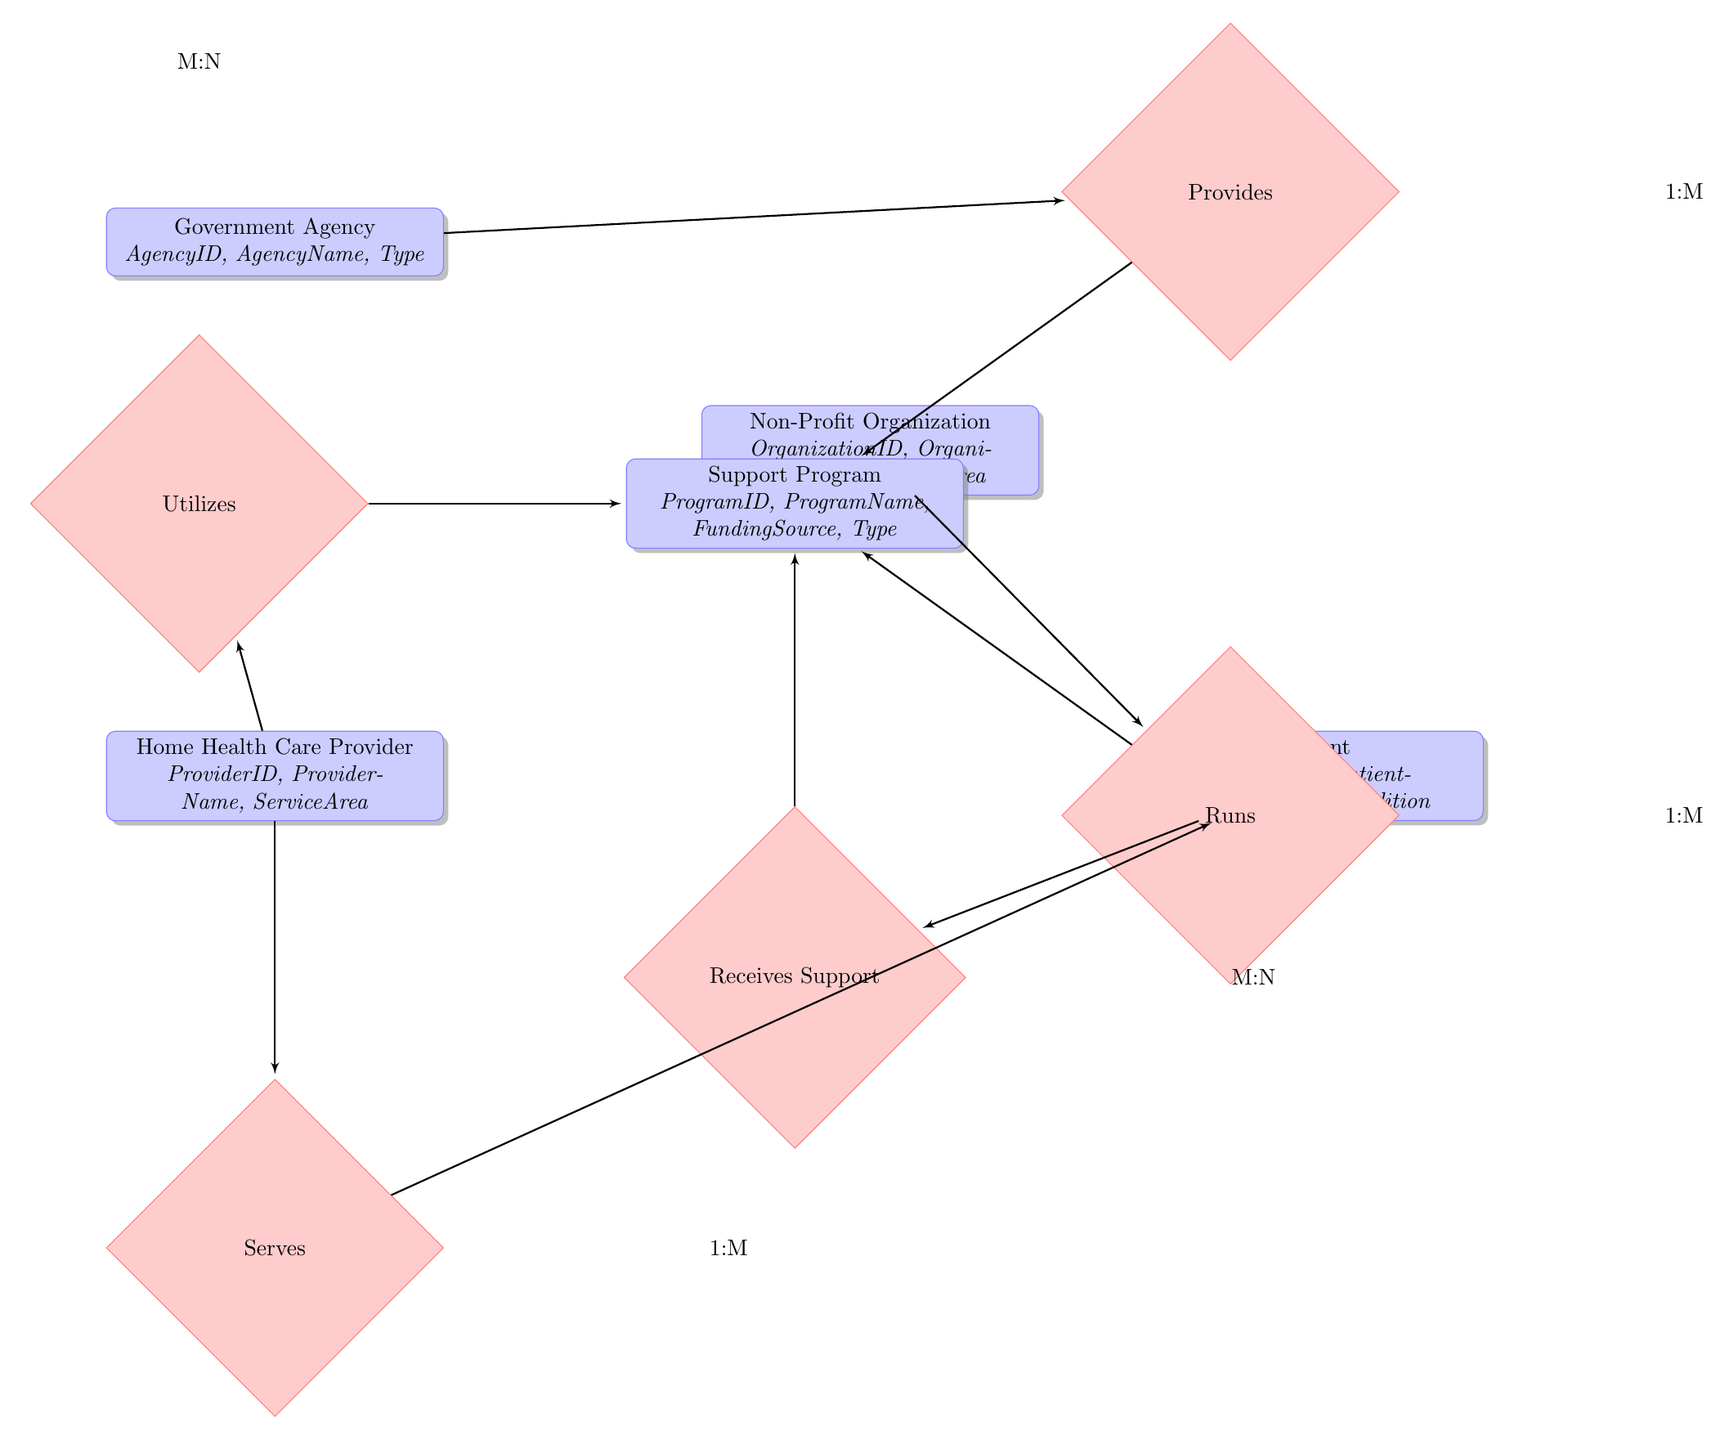What's the total number of entities in the diagram? There are five entities displayed in the diagram: Government Agency, Non-Profit Organization, Support Program, Home Health Care Provider, and Patient.
Answer: 5 What is the relationship type between Government Agency and Support Program? The relationship between Government Agency and Support Program is described as one-to-many, indicating that one government agency can provide multiple support programs.
Answer: one-to-many Which entity utilizes the Support Program? The Home Health Care Provider utilizes the Support Program, as indicated by the relationship named "Utilizes."
Answer: Home Health Care Provider How many relationships are depicted in the diagram? There are five relationships shown in the diagram: Provides, Runs, Utilizes, Serves, and Receives Support.
Answer: 5 What is the focus area of the Non-Profit Organization? The Non-Profit Organization entity has an attribute named "FocusArea," which indicates the specific area the organization focuses on to provide support, but the specific area is not detailed in the diagram itself.
Answer: FocusArea Which entities do patients receive support from? Patients receive support from both Government Agencies and Non-Profit Organizations via Support Programs, demonstrated by the relationship "Receives Support."
Answer: Government Agencies and Non-Profit Organizations How many support programs can a home health care provider utilize? A home health care provider can utilize multiple support programs, as indicated by the many-to-many relationship labeled "Utilizes."
Answer: multiple Which entity serves the Patient? The Home Health Care Provider serves the Patient, as indicated by the relationship "Serves."
Answer: Home Health Care Provider What is the relationship between Patient and Support Program? The relationship between Patient and Support Program is many-to-many, demonstrating that patients can receive support from multiple programs, and one program can support multiple patients.
Answer: many-to-many 